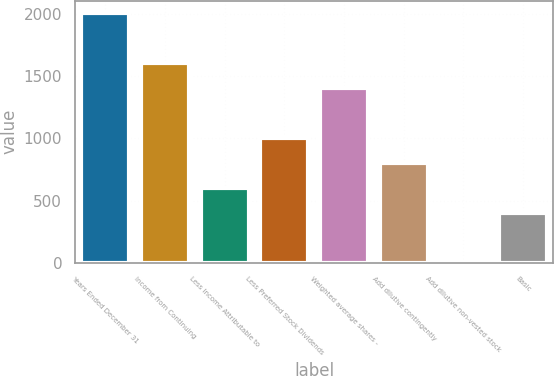Convert chart to OTSL. <chart><loc_0><loc_0><loc_500><loc_500><bar_chart><fcel>Years Ended December 31<fcel>Income from Continuing<fcel>Less Income Attributable to<fcel>Less Preferred Stock Dividends<fcel>Weighted average shares -<fcel>Add dilutive contingently<fcel>Add dilutive non-vested stock<fcel>Basic<nl><fcel>2008<fcel>1606.44<fcel>602.54<fcel>1004.1<fcel>1405.66<fcel>803.32<fcel>0.2<fcel>401.76<nl></chart> 